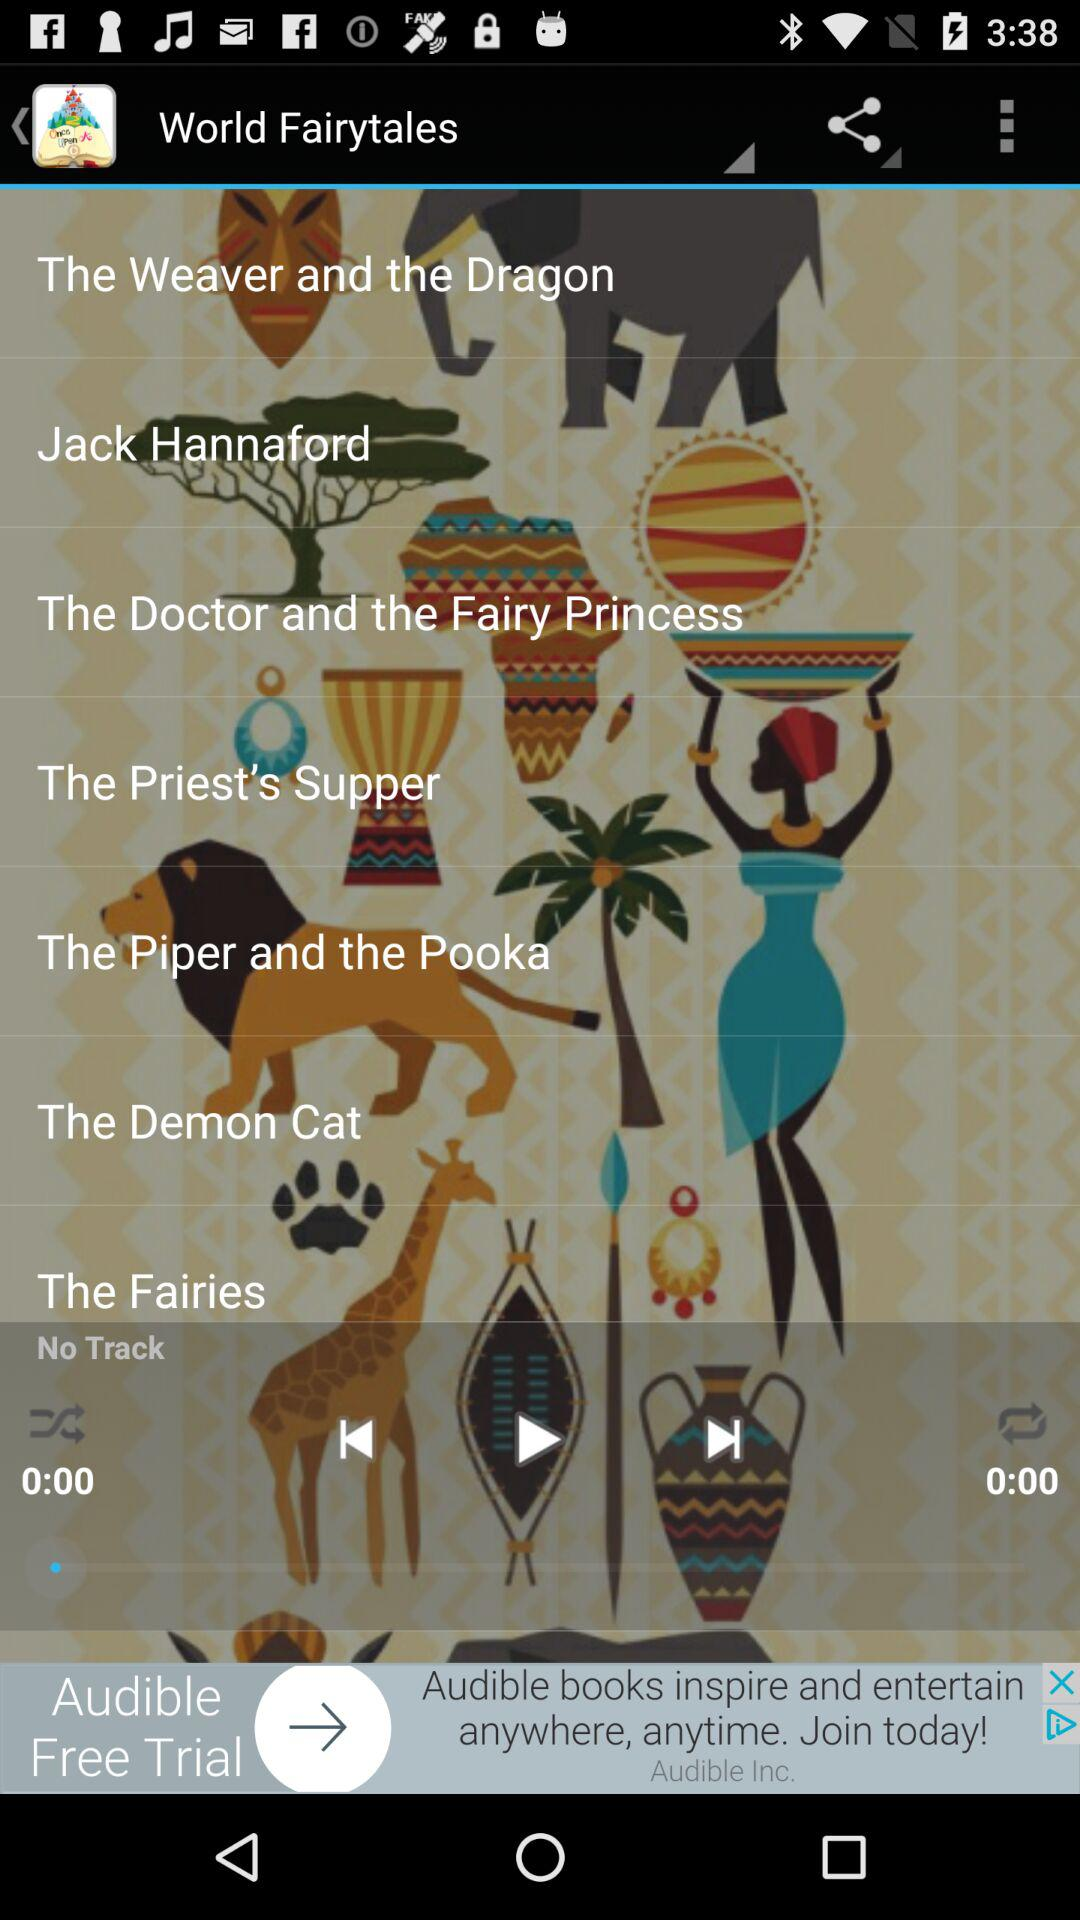Is there any track? There is no track. 